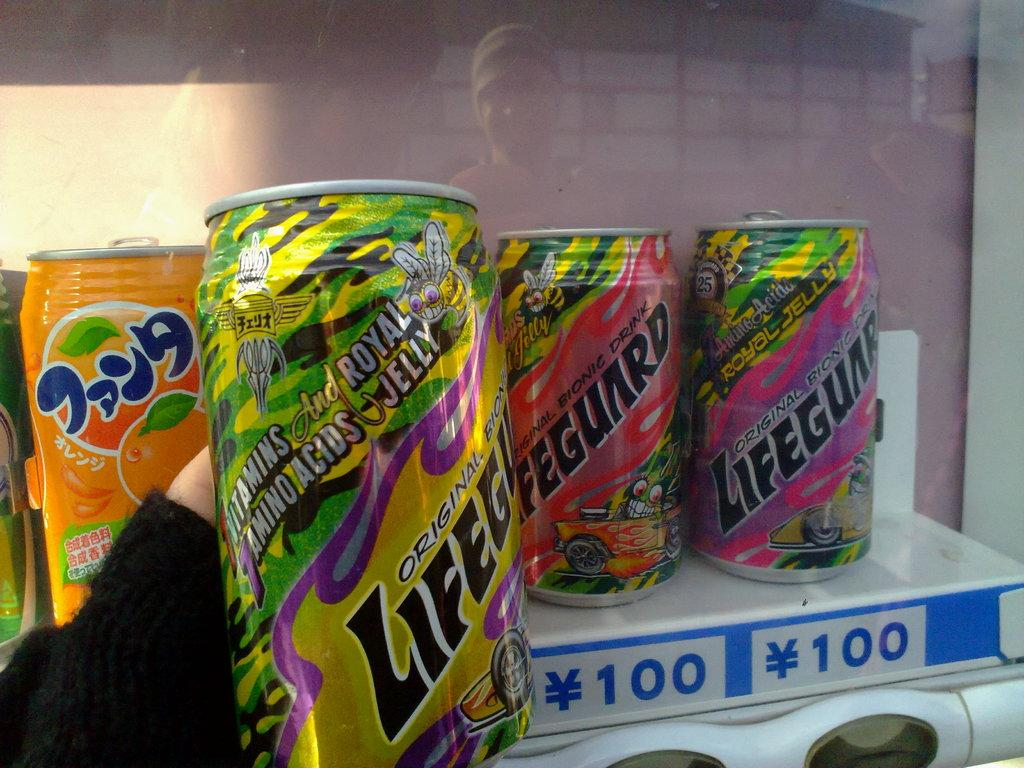<image>
Offer a succinct explanation of the picture presented. Someone is holding a can of Lifeguard drink in front of a vending machine that contains more cans. 